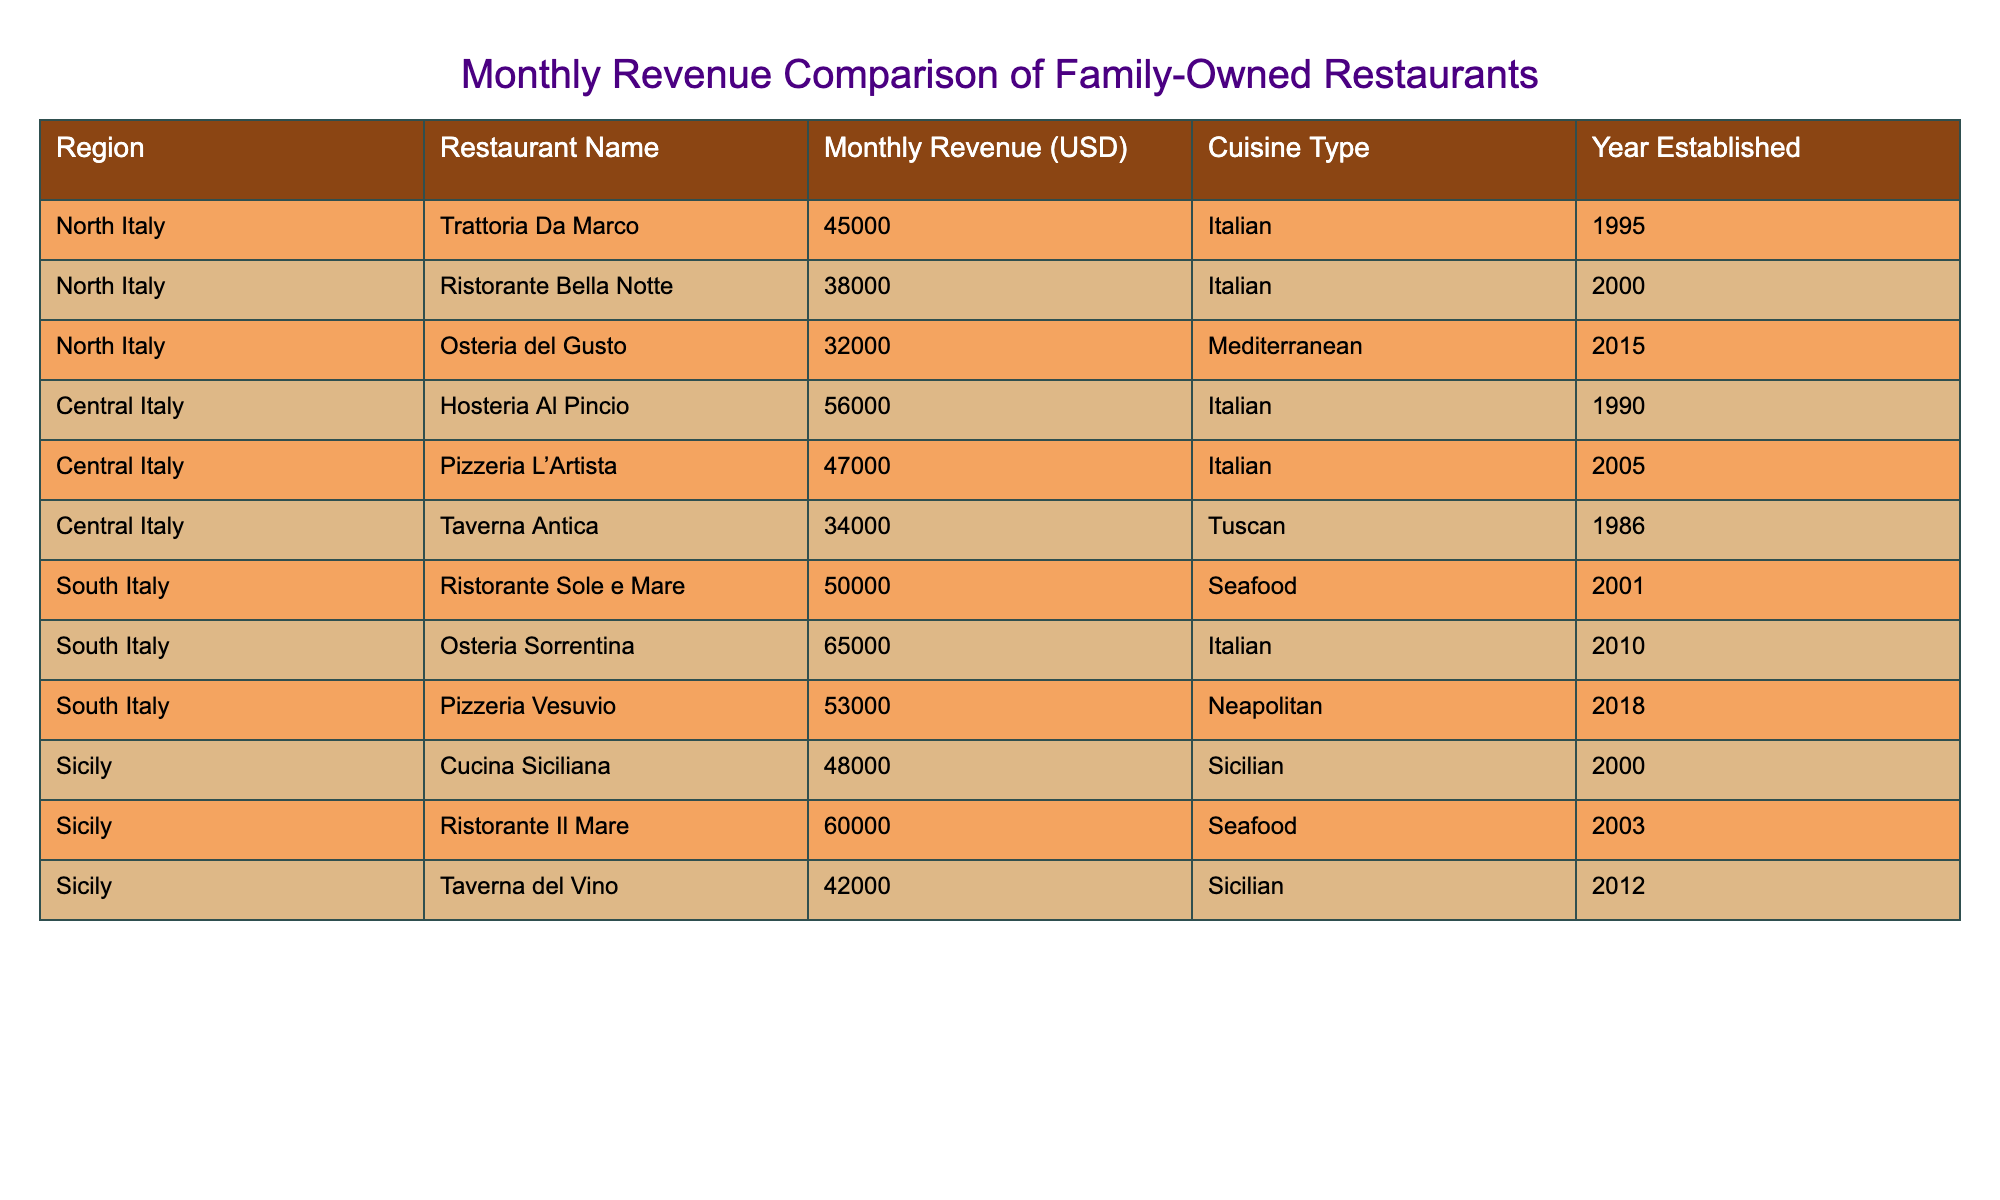What is the highest monthly revenue among the restaurants? By looking at the table, I identify the restaurant with the highest revenue, which is "Osteria Sorrentina" with a revenue of $65,000.
Answer: 65000 Which region has the lowest average monthly revenue for its restaurants? To calculate the average revenue per region: North Italy's total revenue is 115,000 (45,000 + 38,000 + 32,000) divided by 3 gives an average of 38,333. Central Italy's total is 137,000 (56,000 + 47,000 + 34,000) divided by 3 gives an average of 45,667. South Italy's total is 1,83,000 (50,000 + 65,000 + 53,000) divided by 3 gives an average of 56,000. Sicily's total is 1,50,000 (48,000 + 60,000 + 42,000) divided by 3 gives an average of 50,000. The lowest average is thus North Italy.
Answer: North Italy Is there a Mediterranean restaurant in Central Italy? Referring to the table, I search through the rows for any Mediterranean cuisine types in Central Italy, but I only see Italian and Tuscan. Hence, no Mediterranean restaurant exists there.
Answer: No What is the total revenue for South Italy restaurants? I sum the monthly revenues for the restaurants in South Italy: 50,000 (Ristorante Sole e Mare) + 65,000 (Osteria Sorrentina) + 53,000 (Pizzeria Vesuvio) equals a total of 168,000.
Answer: 168000 What percentage of the total revenue in Sicily comes from the highest earning restaurant? First, I find the total revenue for Sicily which is 48,000 + 60,000 + 42,000 = 150,000. The highest revenue here is from Ristorante Il Mare at 60,000. To find the percentage, I calculate (60,000 / 150,000) * 100, giving 40%.
Answer: 40 Which cuisine type earns, on average, the most across all regions? I calculate the average revenue by cuisine type: Italian (average of 49,000), Seafood (average of 58,000), Neapolitan (53,000), Tuscan (34,000), and Sicilian (48,000). Seafood has the highest average of 58,000.
Answer: Seafood Which restaurant was established the earliest in South Italy? I scan through the South Italy entries and find that the earliest established restaurant, Ristorante Sole e Mare, was established in 2001.
Answer: Ristorante Sole e Mare How much more monthly revenue does the highest earning restaurant in Central Italy have compared to the lowest earning restaurant in the same region? In Central Italy, the highest is Hosteria Al Pincio at 56,000 and the lowest is Taverna Antica at 34,000. Calculating the difference gives 56,000 - 34,000 = 22,000.
Answer: 22000 What is the total revenue from all Mediterranean cuisine type restaurants? From the table, only Osteria del Gusto in North Italy is classified as Mediterranean with a revenue of 32,000. Therefore, the total revenue for Mediterranean cuisine type is 32,000.
Answer: 32000 On which side of Italy does "Pizzeria L’Artista" belong? Checking the table, I see "Pizzeria L’Artista" is located in Central Italy.
Answer: Central Italy 